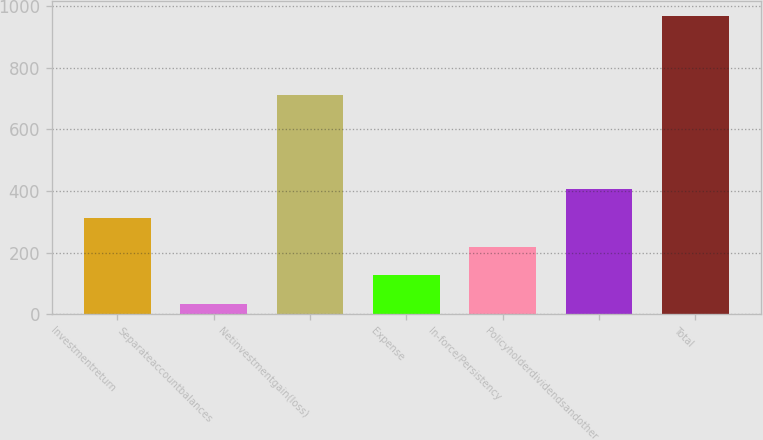<chart> <loc_0><loc_0><loc_500><loc_500><bar_chart><fcel>Investmentreturn<fcel>Separateaccountbalances<fcel>Netinvestmentgain(loss)<fcel>Expense<fcel>In-force/Persistency<fcel>Policyholderdividendsandother<fcel>Total<nl><fcel>312.8<fcel>32<fcel>712<fcel>125.6<fcel>219.2<fcel>406.4<fcel>968<nl></chart> 